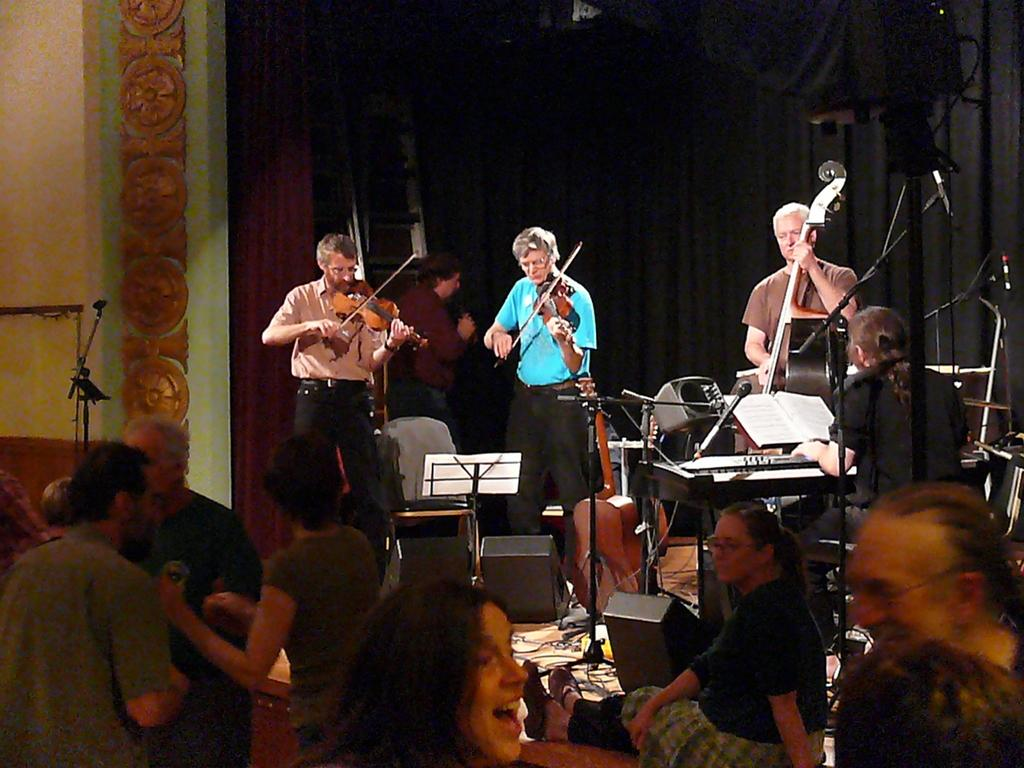What are the people in the image doing? The people in the image are playing musical instruments. Can you describe the setting of the image? There is a wall, a pillow, and a curtain in the background of the image. What might be the purpose of the curtain in the image? The curtain might be used for decoration or to control light in the room. What type of loaf is being used as a drumstick in the image? There is no loaf present in the image, and no drumsticks are being used. 